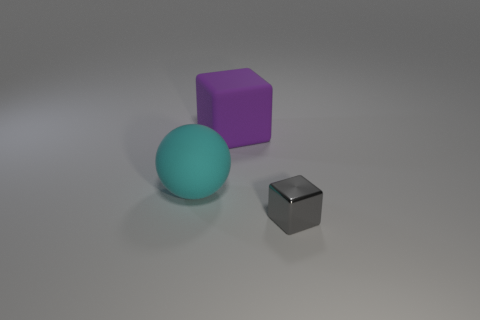Do the rubber cube and the gray metal object have the same size? No, they do not have the same size. The rubber cube appears to be slightly larger than the gray metal object when comparing their dimensions visually. 